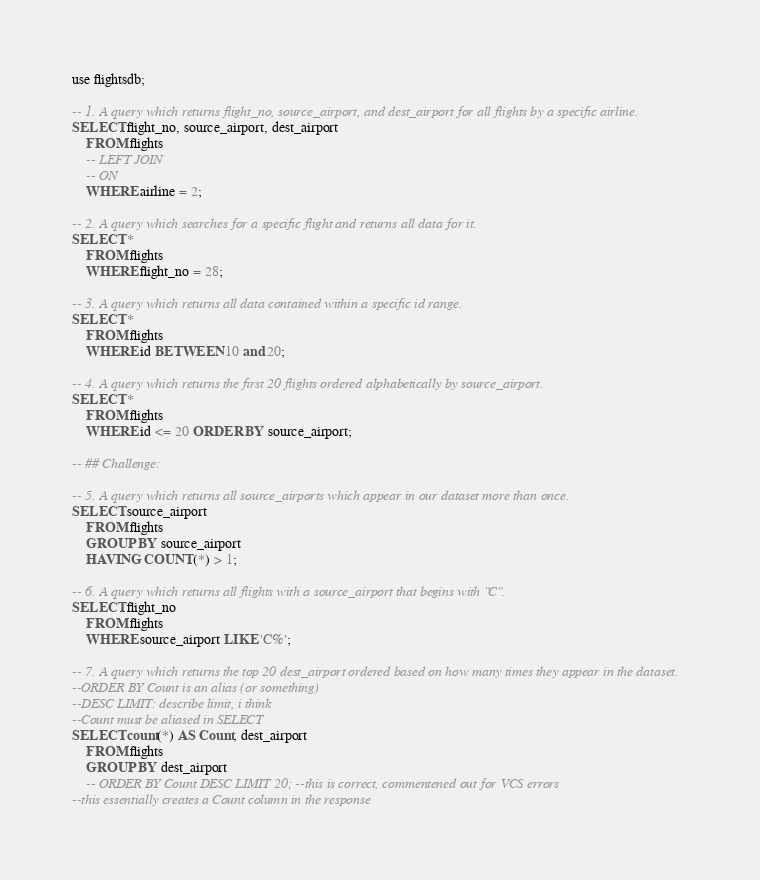<code> <loc_0><loc_0><loc_500><loc_500><_SQL_>use flightsdb;

-- 1. A query which returns flight_no, source_airport, and dest_airport for all flights by a specific airline.
SELECT flight_no, source_airport, dest_airport
    FROM flights
    -- LEFT JOIN
    -- ON
    WHERE airline = 2;

-- 2. A query which searches for a specific flight and returns all data for it.
SELECT *
    FROM flights
    WHERE flight_no = 28;

-- 3. A query which returns all data contained within a specific id range.
SELECT *
    FROM flights
    WHERE id BETWEEN 10 and 20;

-- 4. A query which returns the first 20 flights ordered alphabetically by source_airport.
SELECT *
    FROM flights
    WHERE id <= 20 ORDER BY source_airport;

-- ## Challenge:

-- 5. A query which returns all source_airports which appear in our dataset more than once.
SELECT source_airport
    FROM flights
    GROUP BY source_airport
    HAVING COUNT(*) > 1;

-- 6. A query which returns all flights with a source_airport that begins with "C".
SELECT flight_no
    FROM flights
    WHERE source_airport LIKE 'C%';

-- 7. A query which returns the top 20 dest_airport ordered based on how many times they appear in the dataset.
--ORDER BY Count is an alias (or something)
--DESC LIMIT: describe limit, i think
--Count must be aliased in SELECT
SELECT count(*) AS Count, dest_airport
    FROM flights
    GROUP BY dest_airport
    -- ORDER BY Count DESC LIMIT 20; --this is correct, commentened out for VCS errors
--this essentially creates a Count column in the response</code> 